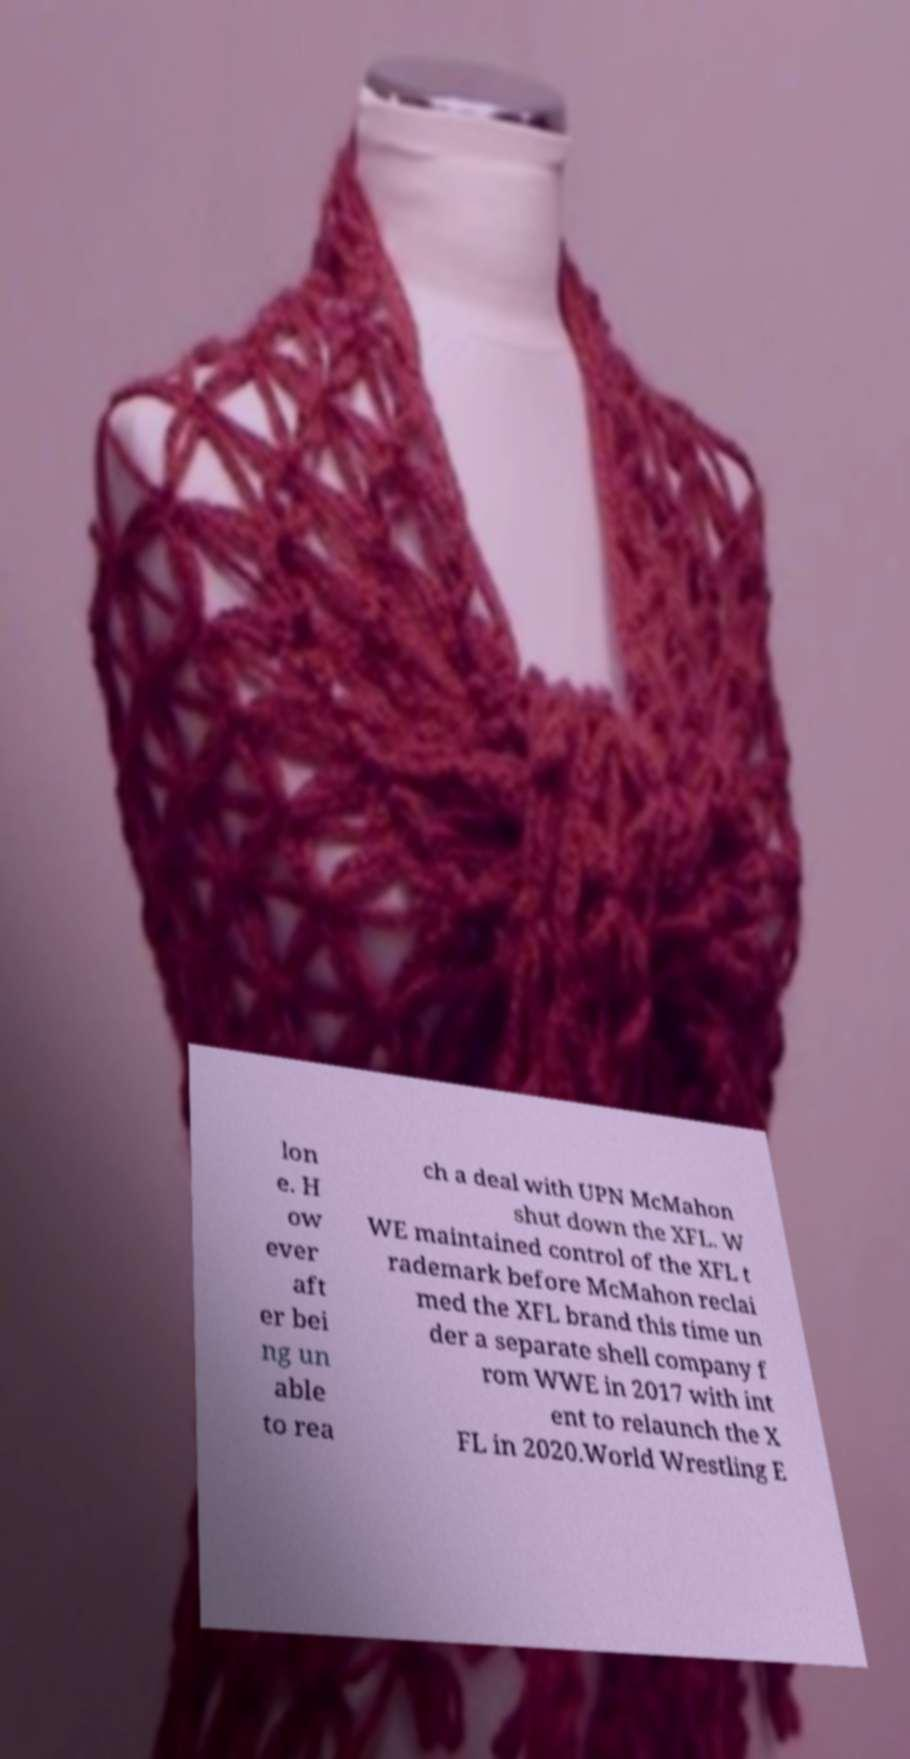For documentation purposes, I need the text within this image transcribed. Could you provide that? lon e. H ow ever aft er bei ng un able to rea ch a deal with UPN McMahon shut down the XFL. W WE maintained control of the XFL t rademark before McMahon reclai med the XFL brand this time un der a separate shell company f rom WWE in 2017 with int ent to relaunch the X FL in 2020.World Wrestling E 